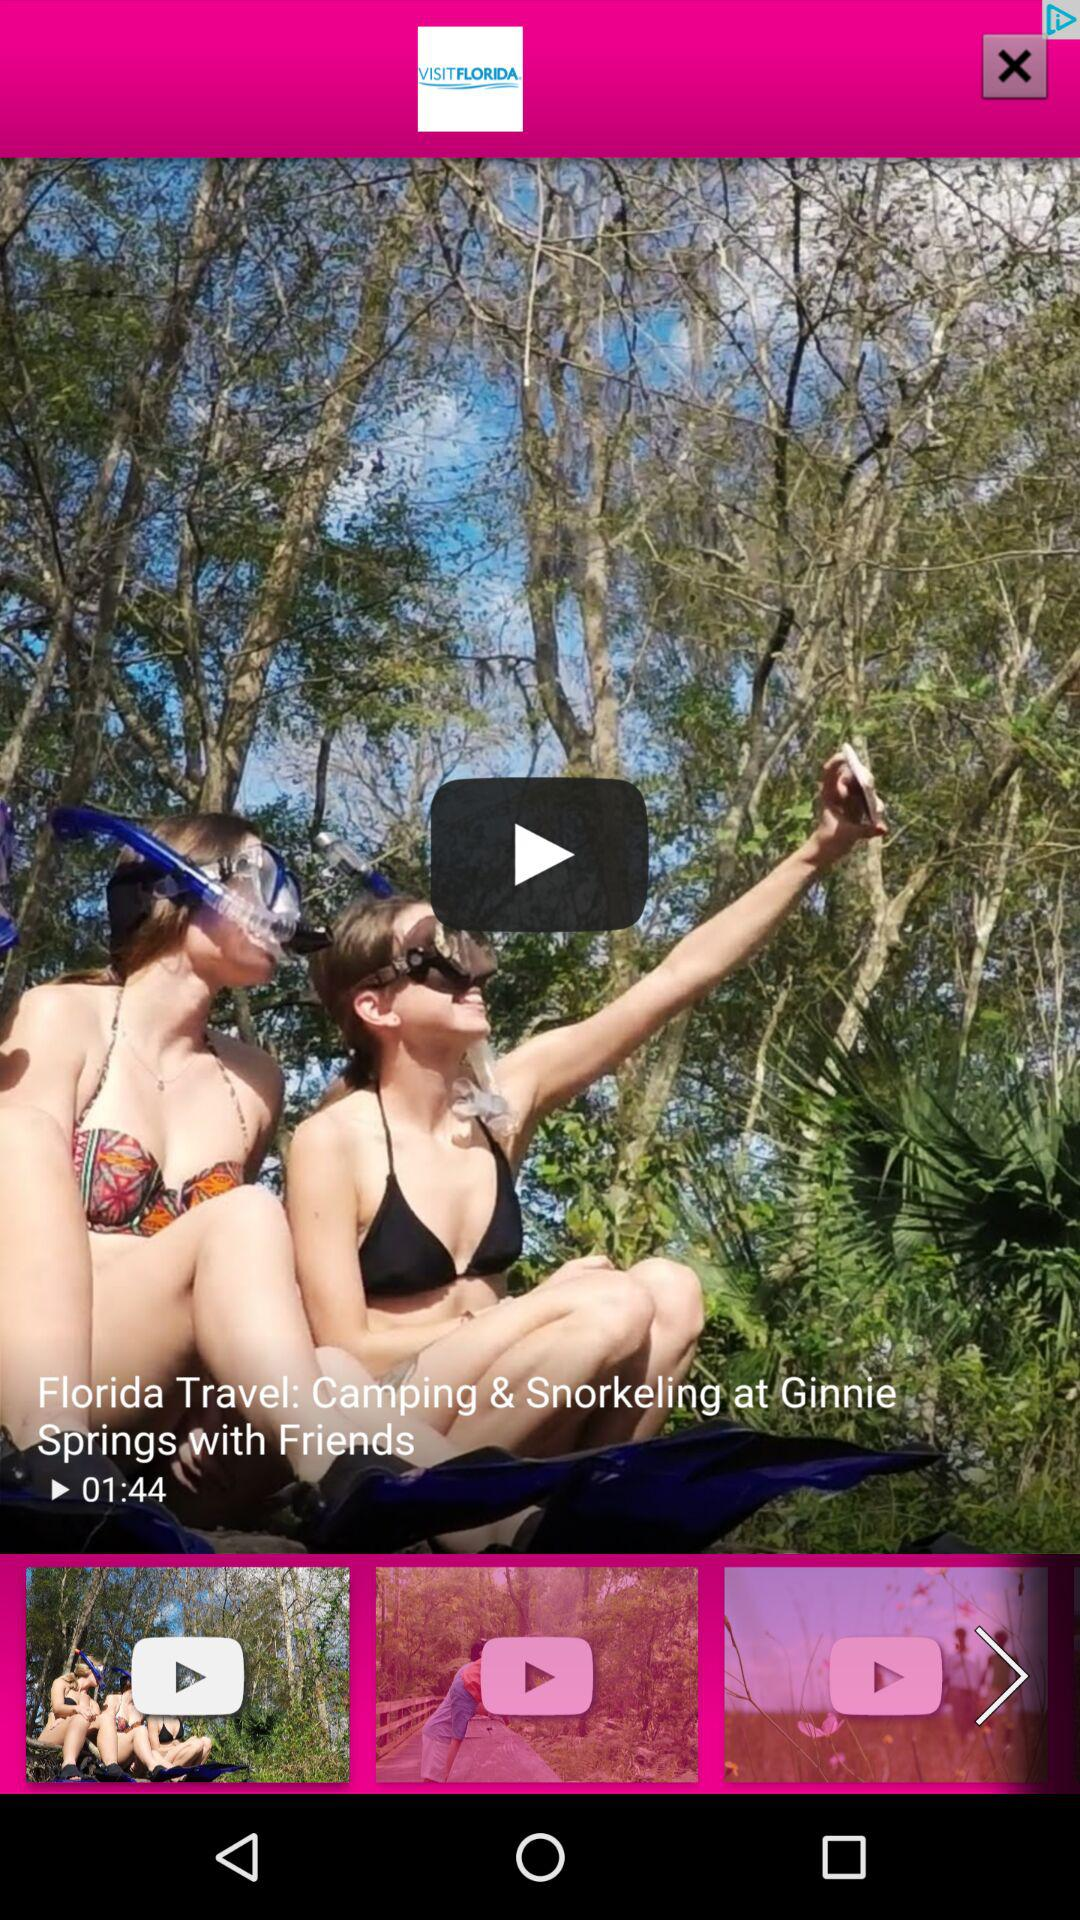What is the duration of the video? The duration of the video is 01:44. 